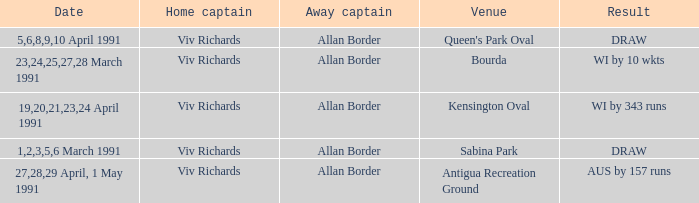What dates had matches at the venue Sabina Park? 1,2,3,5,6 March 1991. I'm looking to parse the entire table for insights. Could you assist me with that? {'header': ['Date', 'Home captain', 'Away captain', 'Venue', 'Result'], 'rows': [['5,6,8,9,10 April 1991', 'Viv Richards', 'Allan Border', "Queen's Park Oval", 'DRAW'], ['23,24,25,27,28 March 1991', 'Viv Richards', 'Allan Border', 'Bourda', 'WI by 10 wkts'], ['19,20,21,23,24 April 1991', 'Viv Richards', 'Allan Border', 'Kensington Oval', 'WI by 343 runs'], ['1,2,3,5,6 March 1991', 'Viv Richards', 'Allan Border', 'Sabina Park', 'DRAW'], ['27,28,29 April, 1 May 1991', 'Viv Richards', 'Allan Border', 'Antigua Recreation Ground', 'AUS by 157 runs']]} 